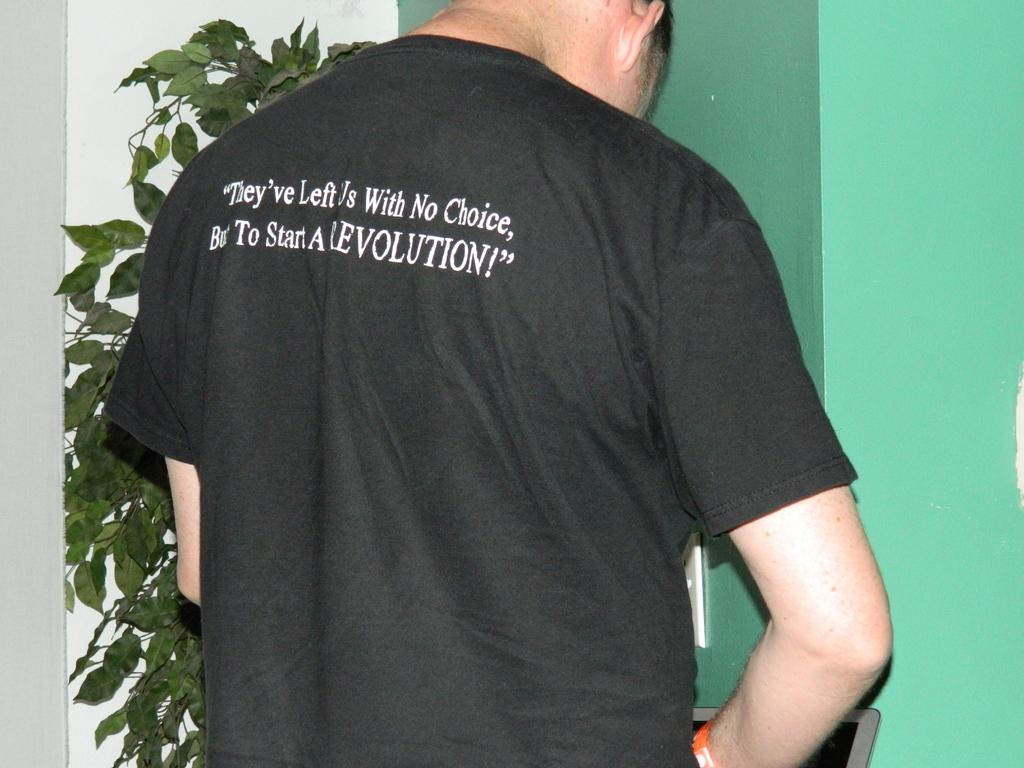<image>
Relay a brief, clear account of the picture shown. A man who appears to be stading at a urinal wearing a black t-shirt espousing his only choice being to start a revolution. 